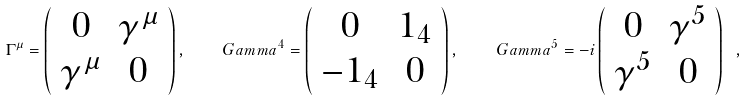Convert formula to latex. <formula><loc_0><loc_0><loc_500><loc_500>\Gamma ^ { \mu } = \left ( \begin{array} { c c } 0 & \gamma ^ { \mu } \\ \gamma ^ { \mu } & 0 \end{array} \right ) , \quad G a m m a ^ { 4 } = \left ( \begin{array} { c c } 0 & 1 _ { 4 } \\ - 1 _ { 4 } & 0 \end{array} \right ) , \quad G a m m a ^ { 5 } = - i \left ( \begin{array} { c c } 0 & \gamma ^ { 5 } \\ \gamma ^ { 5 } & 0 \end{array} \right ) \ ,</formula> 